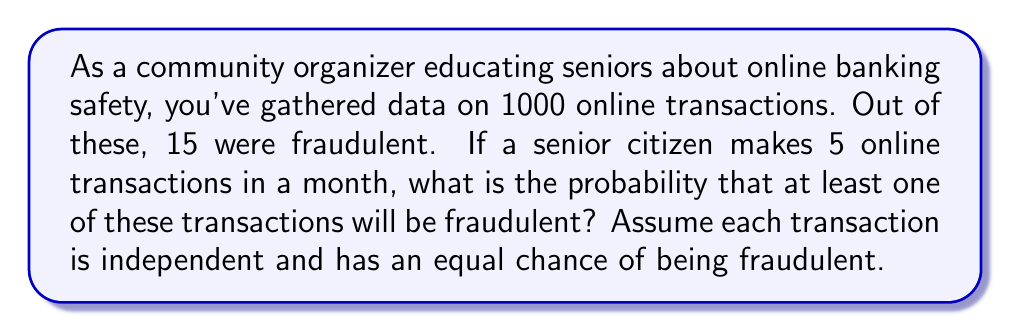Solve this math problem. Let's approach this step-by-step:

1) First, we need to calculate the probability of a single transaction being fraudulent:
   $P(\text{fraudulent}) = \frac{15}{1000} = 0.015 = 1.5\%$

2) The probability of a transaction being legitimate is:
   $P(\text{legitimate}) = 1 - P(\text{fraudulent}) = 1 - 0.015 = 0.985 = 98.5\%$

3) For 5 transactions to all be legitimate, each one must be legitimate:
   $P(\text{all legitimate}) = 0.985^5 \approx 0.9278$

4) The probability of at least one fraudulent transaction is the opposite of all being legitimate:
   $P(\text{at least one fraudulent}) = 1 - P(\text{all legitimate})$
   $= 1 - 0.9278 \approx 0.0722$

5) We can also calculate this using the binomial probability formula:
   $P(X \geq 1) = 1 - P(X = 0)$, where $X$ is the number of fraudulent transactions
   
   $P(X \geq 1) = 1 - \binom{5}{0}(0.015)^0(0.985)^5 \approx 0.0722$

This confirms our earlier calculation.
Answer: $0.0722$ or $7.22\%$ 